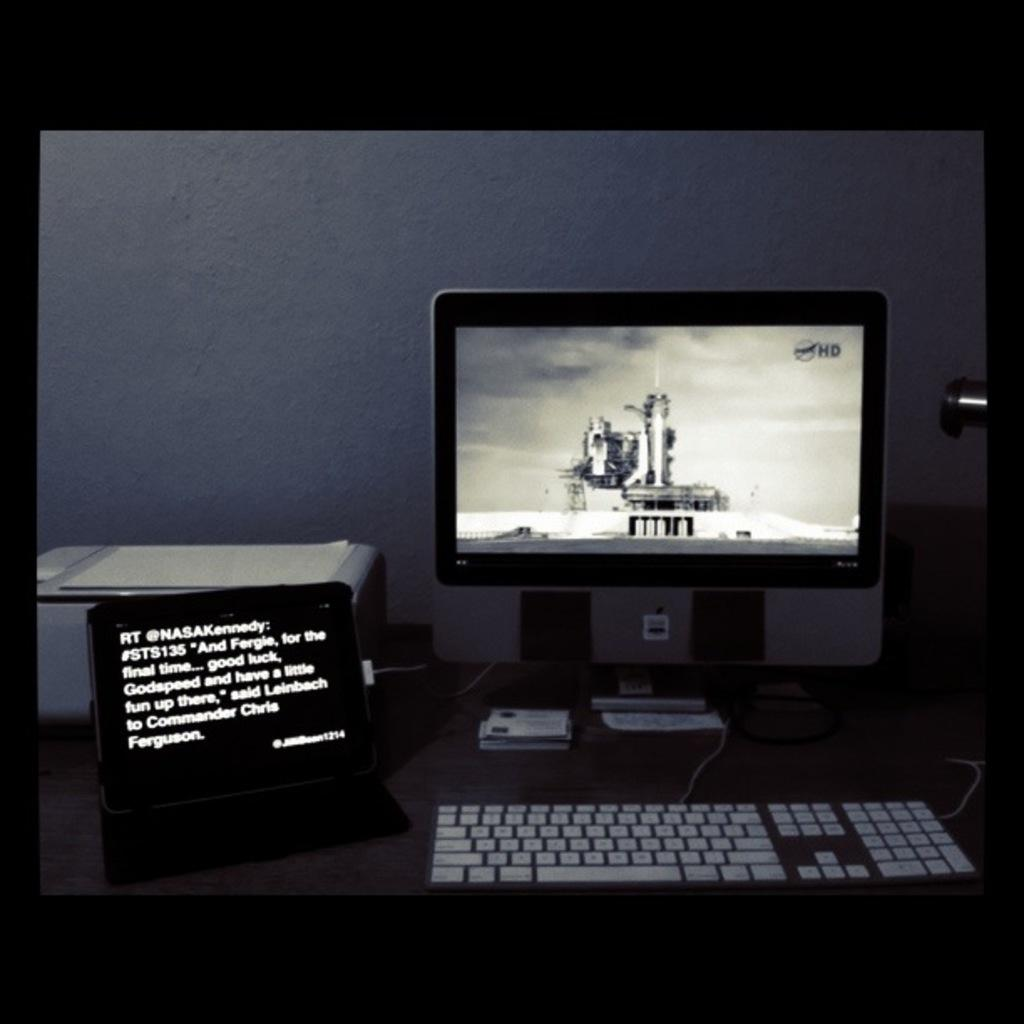<image>
Offer a succinct explanation of the picture presented. A sign on the left says RT @NASAKennedy. 